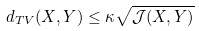<formula> <loc_0><loc_0><loc_500><loc_500>d _ { T V } ( X , Y ) \leq \kappa \sqrt { \mathcal { J } ( X , Y ) }</formula> 